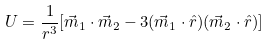Convert formula to latex. <formula><loc_0><loc_0><loc_500><loc_500>U = \frac { 1 } { r ^ { 3 } } [ \vec { m } _ { 1 } \cdot \vec { m } _ { 2 } - 3 ( \vec { m } _ { 1 } \cdot \hat { r } ) ( \vec { m } _ { 2 } \cdot \hat { r } ) ]</formula> 